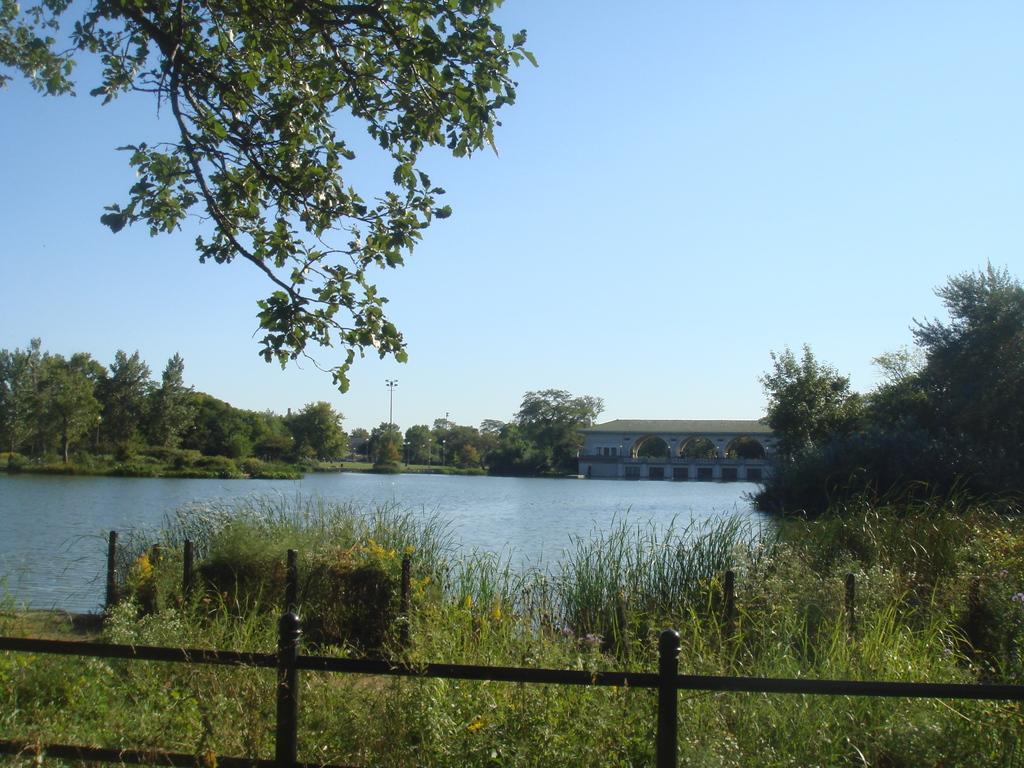Please provide a concise description of this image. In the picture we can see there is grass, fencing, water and in the background of the picture there are some trees, house and top of the picture there is clear sky. 